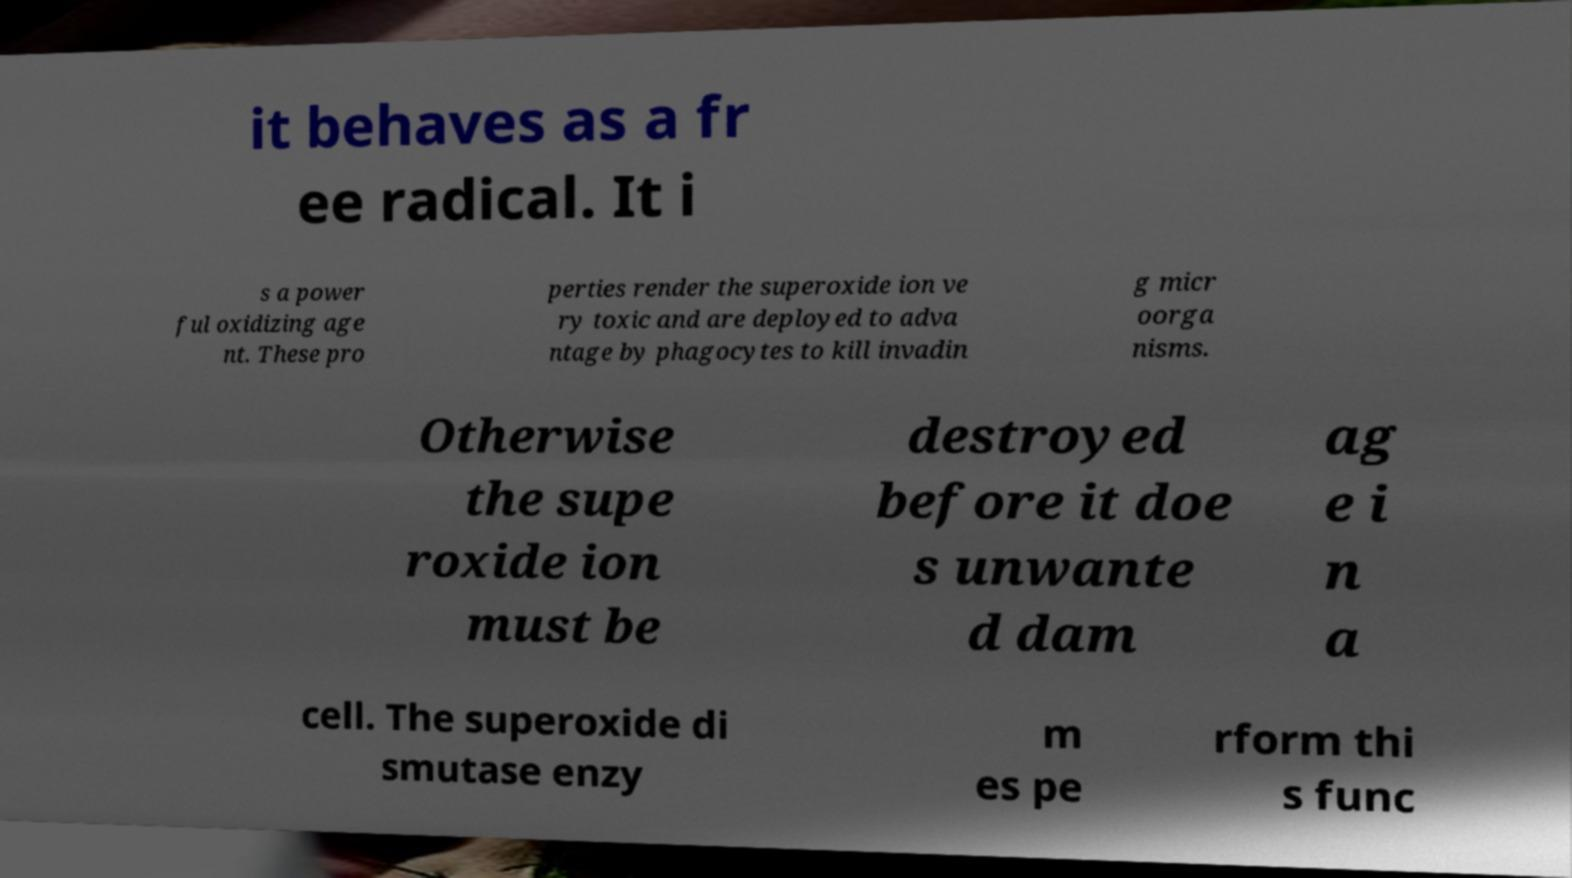Can you read and provide the text displayed in the image?This photo seems to have some interesting text. Can you extract and type it out for me? it behaves as a fr ee radical. It i s a power ful oxidizing age nt. These pro perties render the superoxide ion ve ry toxic and are deployed to adva ntage by phagocytes to kill invadin g micr oorga nisms. Otherwise the supe roxide ion must be destroyed before it doe s unwante d dam ag e i n a cell. The superoxide di smutase enzy m es pe rform thi s func 